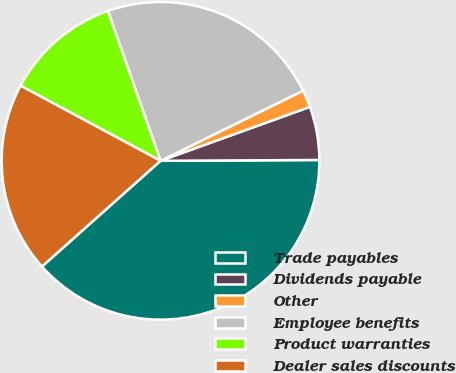<chart> <loc_0><loc_0><loc_500><loc_500><pie_chart><fcel>Trade payables<fcel>Dividends payable<fcel>Other<fcel>Employee benefits<fcel>Product warranties<fcel>Dealer sales discounts<nl><fcel>38.49%<fcel>5.43%<fcel>1.76%<fcel>23.1%<fcel>11.78%<fcel>19.43%<nl></chart> 